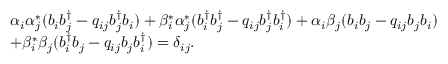Convert formula to latex. <formula><loc_0><loc_0><loc_500><loc_500>\begin{array} { l } { { \alpha _ { i } \alpha _ { j } ^ { * } ( b _ { i } b _ { j } ^ { \dagger } - q _ { i j } b _ { j } ^ { \dagger } b _ { i } ) + \beta _ { i } ^ { * } \alpha _ { j } ^ { * } ( b _ { i } ^ { \dagger } b _ { j } ^ { \dagger } - q _ { i j } b _ { j } ^ { \dagger } b _ { i } ^ { \dagger } ) + \alpha _ { i } \beta _ { j } ( b _ { i } b _ { j } - q _ { i j } b _ { j } b _ { i } ) } } \\ { { + \beta _ { i } ^ { * } \beta _ { j } ( b _ { i } ^ { \dagger } b _ { j } - q _ { i j } b _ { j } b _ { i } ^ { \dagger } ) = \delta _ { i j } . } } \end{array}</formula> 